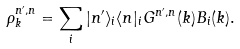<formula> <loc_0><loc_0><loc_500><loc_500>\rho _ { k } ^ { n ^ { \prime } , n } = \sum _ { i } | n ^ { \prime } \rangle _ { i } \langle n | _ { i } G ^ { n ^ { \prime } , n } ( k ) B _ { i } ( k ) .</formula> 